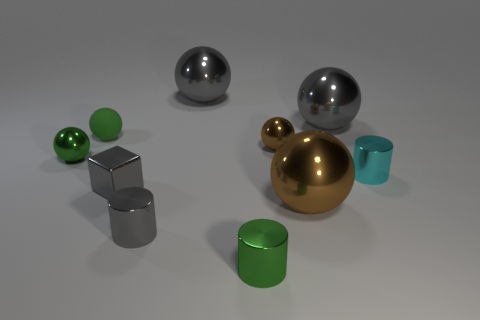Subtract 1 spheres. How many spheres are left? 5 Subtract all brown balls. How many balls are left? 4 Subtract all gray metal spheres. How many spheres are left? 4 Subtract all red balls. Subtract all gray blocks. How many balls are left? 6 Subtract all cylinders. How many objects are left? 7 Add 2 green metal things. How many green metal things exist? 4 Subtract 0 yellow cylinders. How many objects are left? 10 Subtract all green metallic cylinders. Subtract all small cyan objects. How many objects are left? 8 Add 2 green metallic cylinders. How many green metallic cylinders are left? 3 